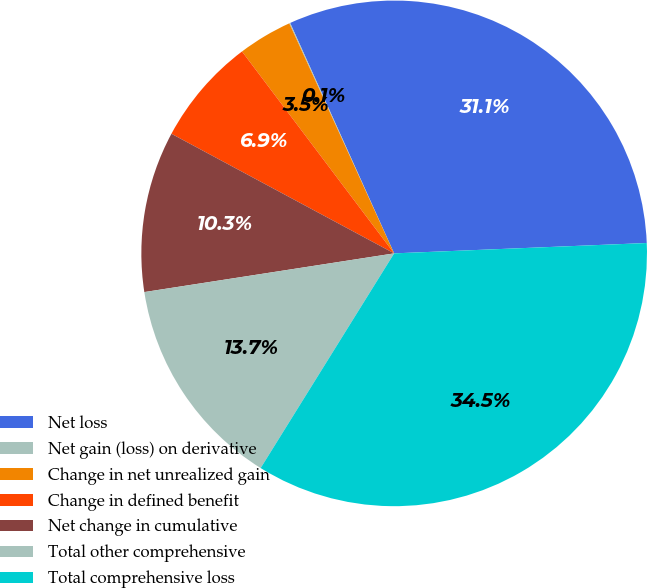Convert chart. <chart><loc_0><loc_0><loc_500><loc_500><pie_chart><fcel>Net loss<fcel>Net gain (loss) on derivative<fcel>Change in net unrealized gain<fcel>Change in defined benefit<fcel>Net change in cumulative<fcel>Total other comprehensive<fcel>Total comprehensive loss<nl><fcel>31.1%<fcel>0.06%<fcel>3.47%<fcel>6.88%<fcel>10.29%<fcel>13.7%<fcel>34.51%<nl></chart> 